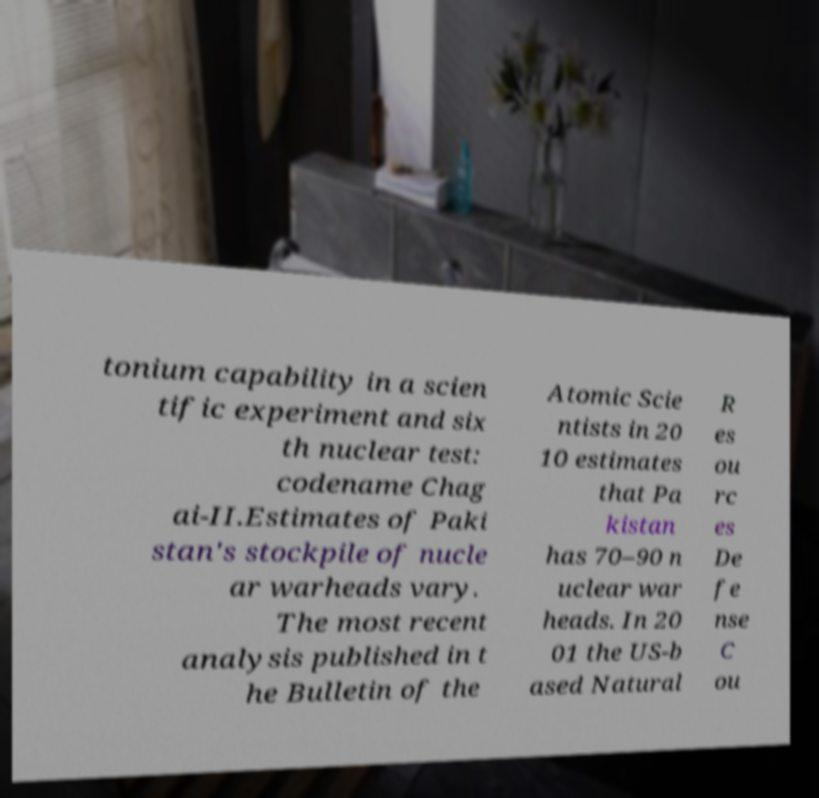Can you read and provide the text displayed in the image?This photo seems to have some interesting text. Can you extract and type it out for me? tonium capability in a scien tific experiment and six th nuclear test: codename Chag ai-II.Estimates of Paki stan's stockpile of nucle ar warheads vary. The most recent analysis published in t he Bulletin of the Atomic Scie ntists in 20 10 estimates that Pa kistan has 70–90 n uclear war heads. In 20 01 the US-b ased Natural R es ou rc es De fe nse C ou 